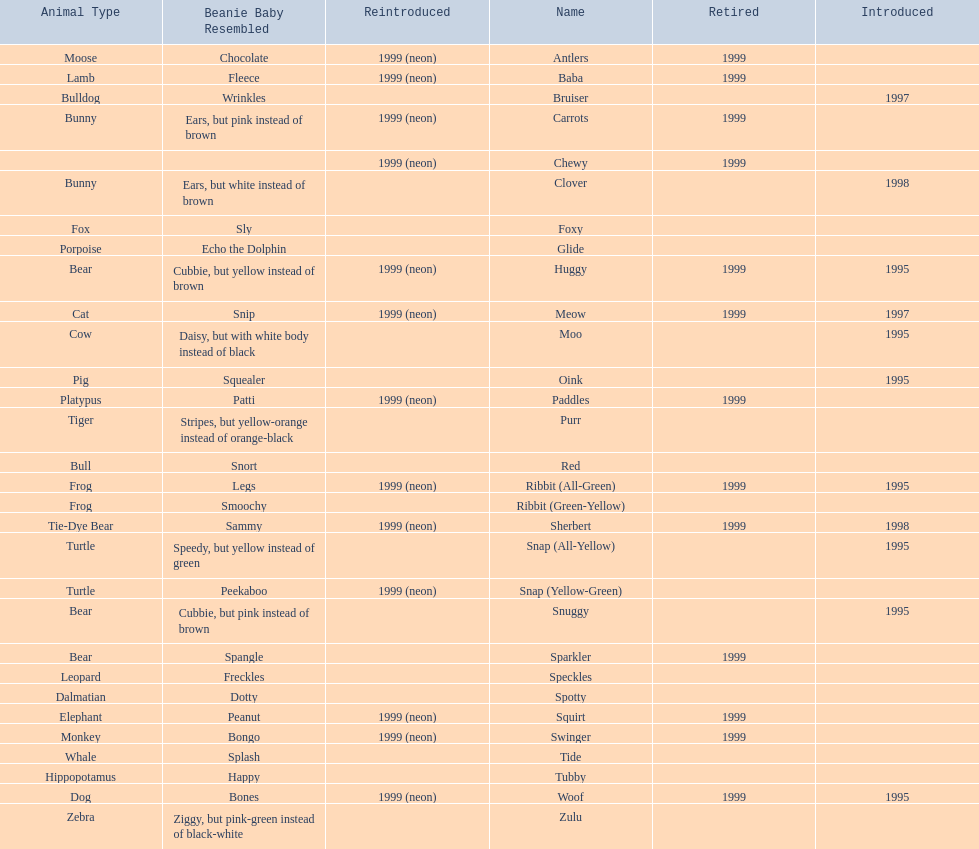What is the overall count of pillow pals that were re-launched in a neon version? 13. 